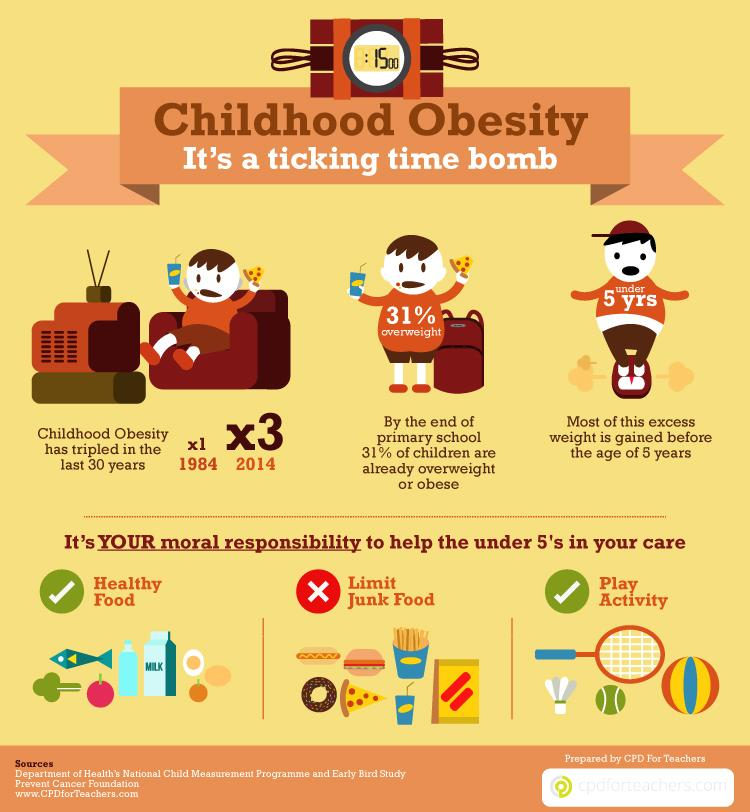Outline some significant characteristics in this image. There are two balls depicted in this infographic. There are three children depicted in this infographic. According to the data, only 69% of children are not overweight. There are two dos in this infographic. There is one don't in this infographic. 